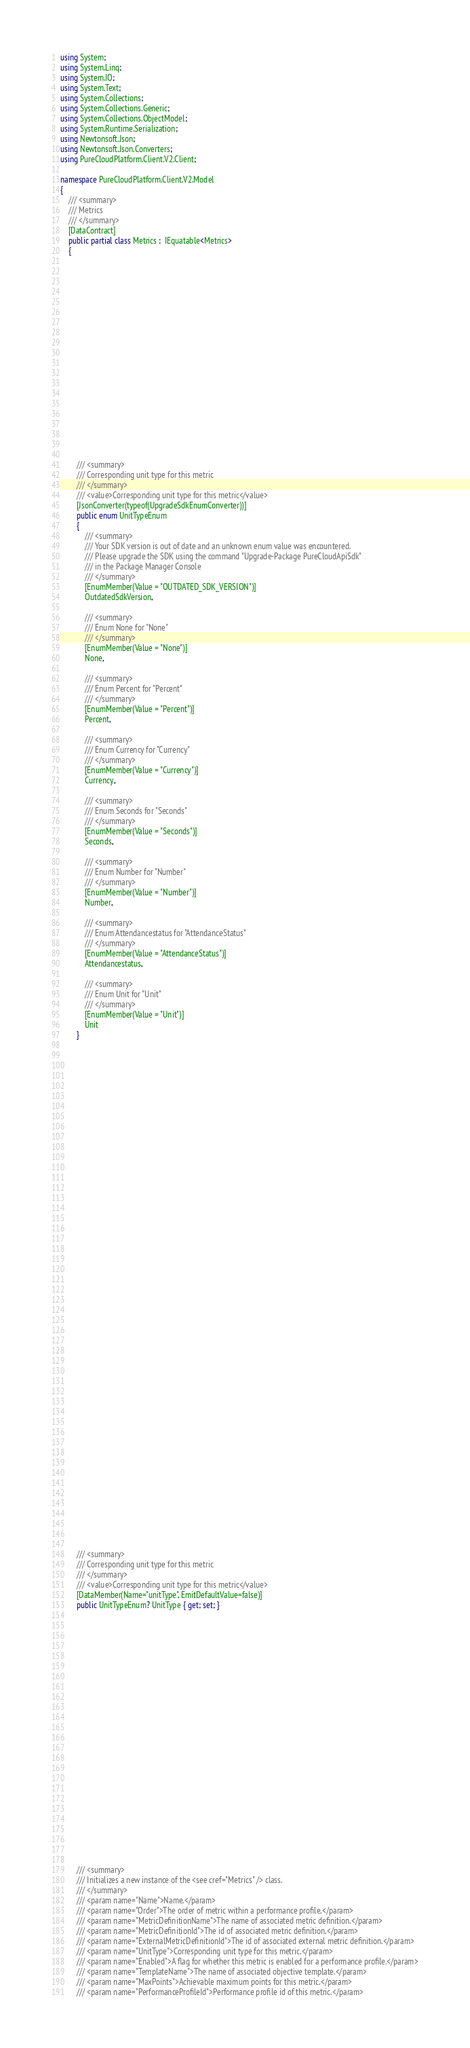<code> <loc_0><loc_0><loc_500><loc_500><_C#_>using System;
using System.Linq;
using System.IO;
using System.Text;
using System.Collections;
using System.Collections.Generic;
using System.Collections.ObjectModel;
using System.Runtime.Serialization;
using Newtonsoft.Json;
using Newtonsoft.Json.Converters;
using PureCloudPlatform.Client.V2.Client;

namespace PureCloudPlatform.Client.V2.Model
{
    /// <summary>
    /// Metrics
    /// </summary>
    [DataContract]
    public partial class Metrics :  IEquatable<Metrics>
    {
        
        
        
        
        
        
        
        
        
        
        
        
        
        
        
        
        
        
        
        
        /// <summary>
        /// Corresponding unit type for this metric
        /// </summary>
        /// <value>Corresponding unit type for this metric</value>
        [JsonConverter(typeof(UpgradeSdkEnumConverter))]
        public enum UnitTypeEnum
        {
            /// <summary>
            /// Your SDK version is out of date and an unknown enum value was encountered. 
            /// Please upgrade the SDK using the command "Upgrade-Package PureCloudApiSdk" 
            /// in the Package Manager Console
            /// </summary>
            [EnumMember(Value = "OUTDATED_SDK_VERSION")]
            OutdatedSdkVersion,
            
            /// <summary>
            /// Enum None for "None"
            /// </summary>
            [EnumMember(Value = "None")]
            None,
            
            /// <summary>
            /// Enum Percent for "Percent"
            /// </summary>
            [EnumMember(Value = "Percent")]
            Percent,
            
            /// <summary>
            /// Enum Currency for "Currency"
            /// </summary>
            [EnumMember(Value = "Currency")]
            Currency,
            
            /// <summary>
            /// Enum Seconds for "Seconds"
            /// </summary>
            [EnumMember(Value = "Seconds")]
            Seconds,
            
            /// <summary>
            /// Enum Number for "Number"
            /// </summary>
            [EnumMember(Value = "Number")]
            Number,
            
            /// <summary>
            /// Enum Attendancestatus for "AttendanceStatus"
            /// </summary>
            [EnumMember(Value = "AttendanceStatus")]
            Attendancestatus,
            
            /// <summary>
            /// Enum Unit for "Unit"
            /// </summary>
            [EnumMember(Value = "Unit")]
            Unit
        }
        
        
        
        
        
        
        
        
        
        
        
        
        
        
        
        
        
        
        
        
        
        
        
        
        
        
        
        
        
        
        
        
        
        
        
        
        
        
        
        
        
        
        
        
        
        
        
        
        
        
        /// <summary>
        /// Corresponding unit type for this metric
        /// </summary>
        /// <value>Corresponding unit type for this metric</value>
        [DataMember(Name="unitType", EmitDefaultValue=false)]
        public UnitTypeEnum? UnitType { get; set; }
        
        
        
        
        
        
        
        
        
        
        
        
        
        
        
        
        
        
        
        
        
        
        
        
    
        /// <summary>
        /// Initializes a new instance of the <see cref="Metrics" /> class.
        /// </summary>
        /// <param name="Name">Name.</param>
        /// <param name="Order">The order of metric within a performance profile.</param>
        /// <param name="MetricDefinitionName">The name of associated metric definition.</param>
        /// <param name="MetricDefinitionId">The id of associated metric definition.</param>
        /// <param name="ExternalMetricDefinitionId">The id of associated external metric definition.</param>
        /// <param name="UnitType">Corresponding unit type for this metric.</param>
        /// <param name="Enabled">A flag for whether this metric is enabled for a performance profile.</param>
        /// <param name="TemplateName">The name of associated objective template.</param>
        /// <param name="MaxPoints">Achievable maximum points for this metric.</param>
        /// <param name="PerformanceProfileId">Performance profile id of this metric.</param></code> 